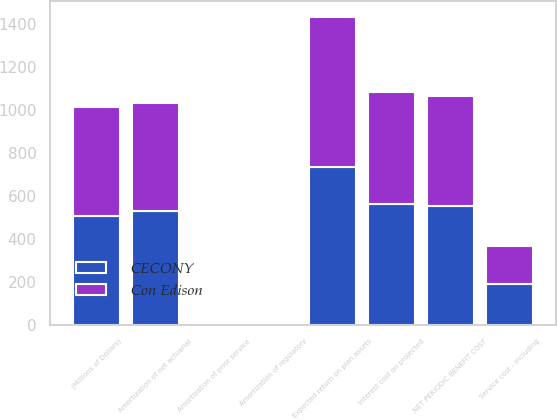Convert chart to OTSL. <chart><loc_0><loc_0><loc_500><loc_500><stacked_bar_chart><ecel><fcel>(Millions of Dollars)<fcel>Service cost - including<fcel>Interest cost on projected<fcel>Expected return on plan assets<fcel>Amortization of net actuarial<fcel>Amortization of prior service<fcel>NET PERIODIC BENEFIT COST<fcel>Amortization of regulatory<nl><fcel>CECONY<fcel>505.5<fcel>190<fcel>560<fcel>734<fcel>530<fcel>8<fcel>554<fcel>2<nl><fcel>Con Edison<fcel>505.5<fcel>177<fcel>524<fcel>698<fcel>501<fcel>6<fcel>510<fcel>2<nl></chart> 